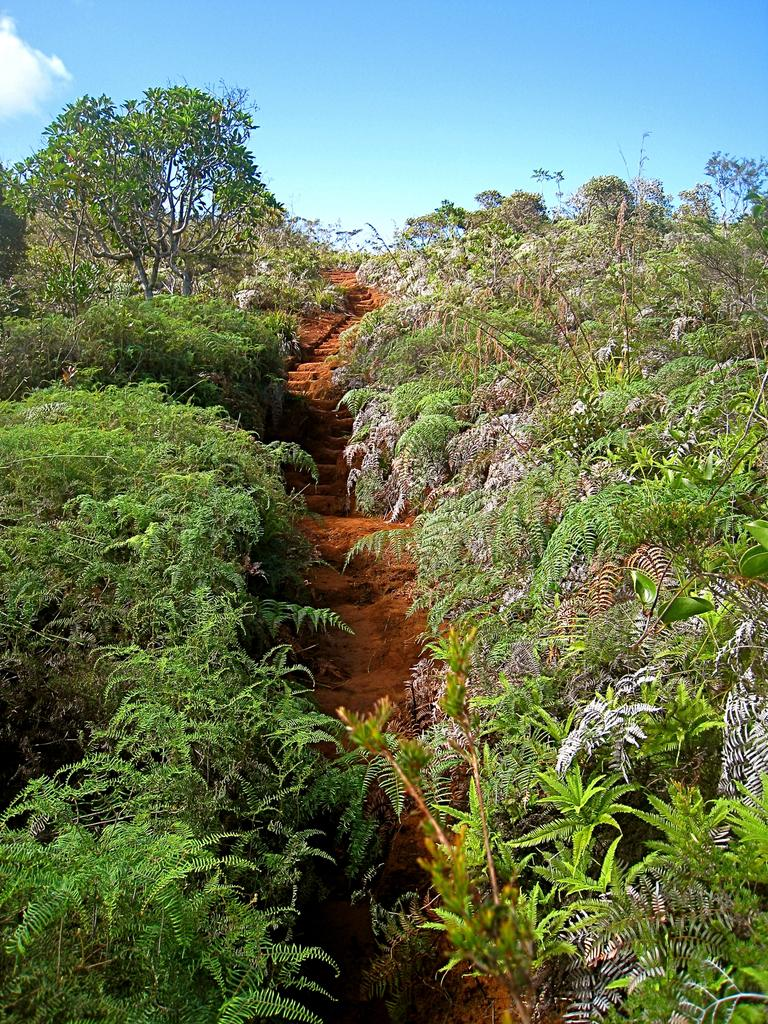What type of vegetation can be seen in the image? There are trees in the image. What is the ground made of in the image? Soil is visible in the image. What is visible in the background of the image? The sky is visible in the background of the image. What type of crate is being used to transport the wood in the image? There is no crate or wood present in the image; it only features trees and soil. What channel is being used to irrigate the trees in the image? There is no irrigation channel visible in the image; it only shows trees and soil. 